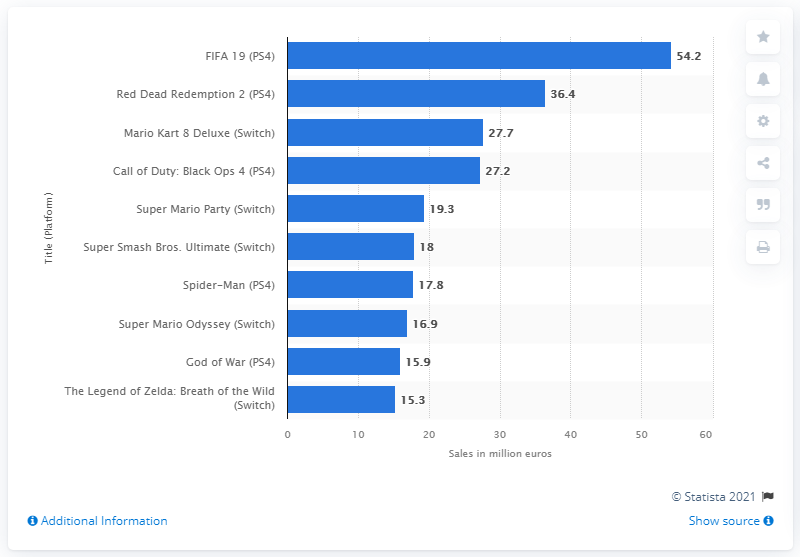Specify some key components in this picture. FIFA 19 generated $54.2 billion in sales in 2018. 